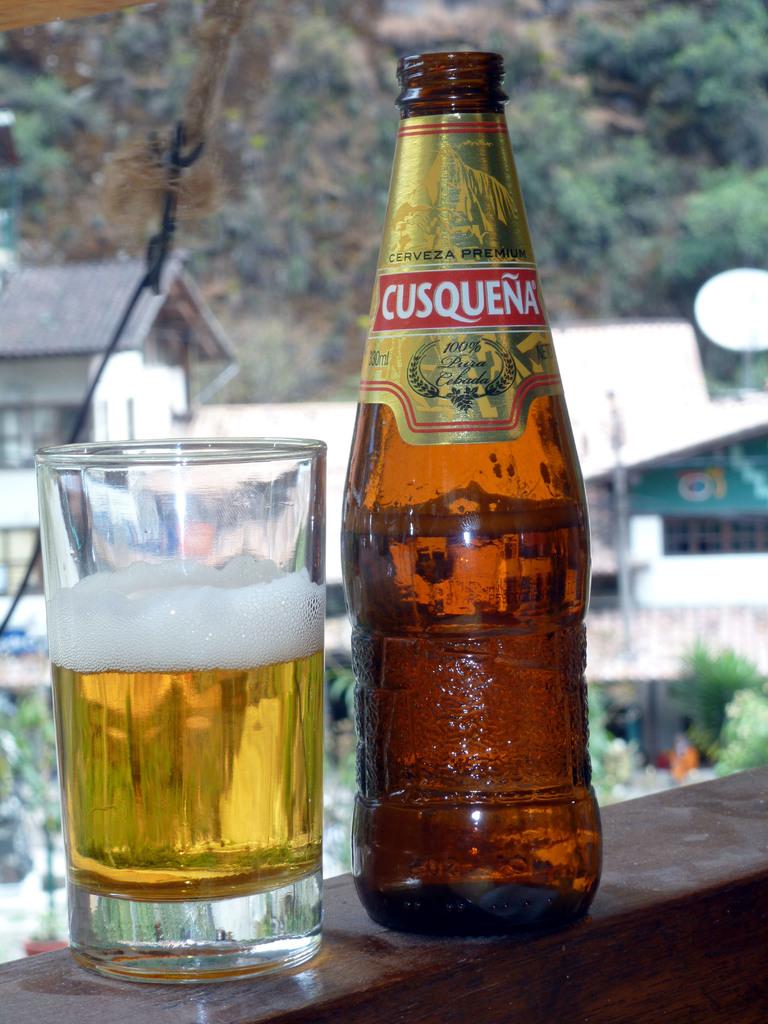What is the brand of beer shown?
Give a very brief answer. Cusquena. 